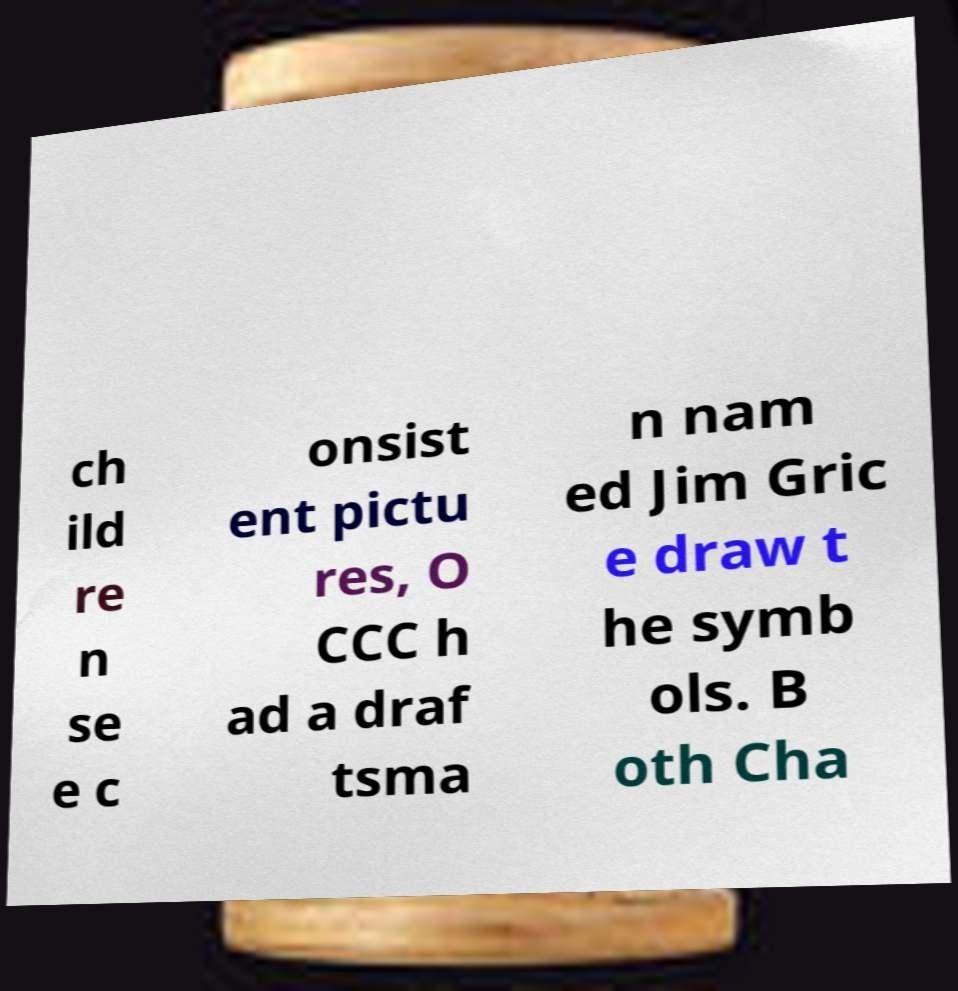Could you extract and type out the text from this image? ch ild re n se e c onsist ent pictu res, O CCC h ad a draf tsma n nam ed Jim Gric e draw t he symb ols. B oth Cha 